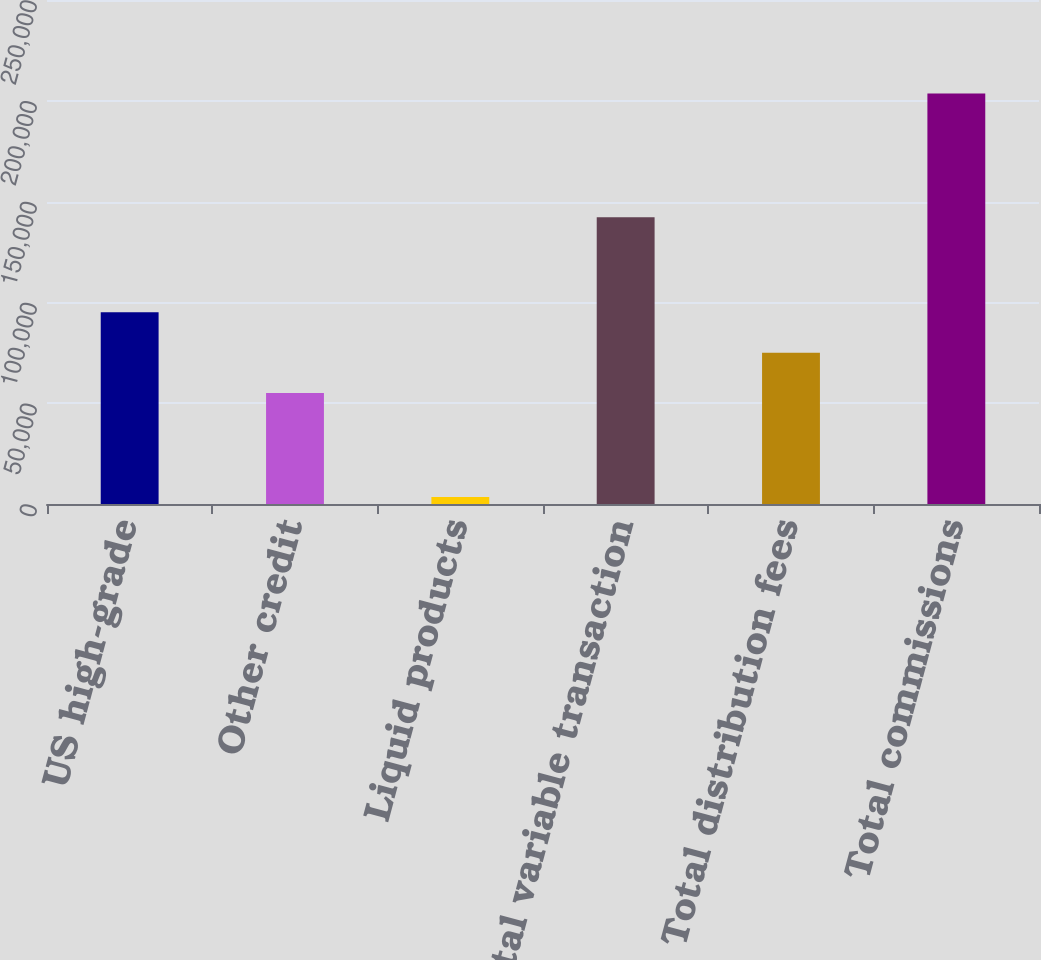Convert chart. <chart><loc_0><loc_0><loc_500><loc_500><bar_chart><fcel>US high-grade<fcel>Other credit<fcel>Liquid products<fcel>Total variable transaction<fcel>Total distribution fees<fcel>Total commissions<nl><fcel>95090.4<fcel>55046<fcel>3430<fcel>142293<fcel>75068.2<fcel>203652<nl></chart> 